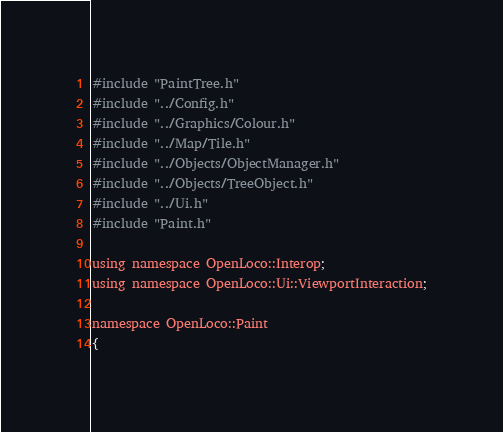<code> <loc_0><loc_0><loc_500><loc_500><_C++_>#include "PaintTree.h"
#include "../Config.h"
#include "../Graphics/Colour.h"
#include "../Map/Tile.h"
#include "../Objects/ObjectManager.h"
#include "../Objects/TreeObject.h"
#include "../Ui.h"
#include "Paint.h"

using namespace OpenLoco::Interop;
using namespace OpenLoco::Ui::ViewportInteraction;

namespace OpenLoco::Paint
{</code> 